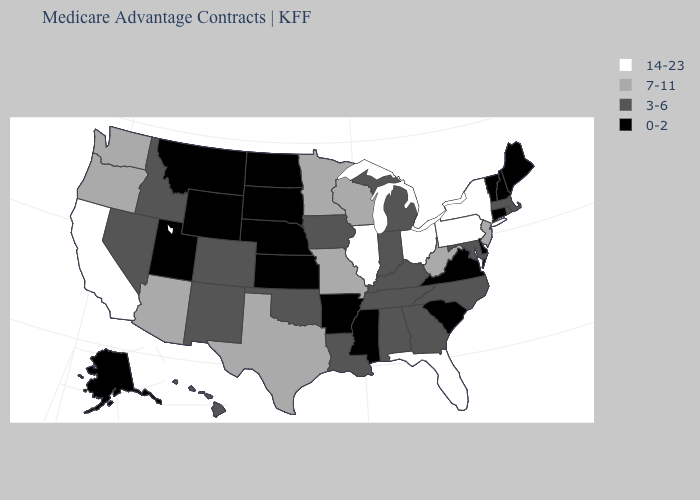What is the value of South Carolina?
Answer briefly. 0-2. Which states hav the highest value in the MidWest?
Give a very brief answer. Illinois, Ohio. Among the states that border Mississippi , which have the lowest value?
Quick response, please. Arkansas. Name the states that have a value in the range 3-6?
Keep it brief. Alabama, Colorado, Georgia, Hawaii, Iowa, Idaho, Indiana, Kentucky, Louisiana, Massachusetts, Maryland, Michigan, North Carolina, New Mexico, Nevada, Oklahoma, Rhode Island, Tennessee. Name the states that have a value in the range 7-11?
Write a very short answer. Arizona, Minnesota, Missouri, New Jersey, Oregon, Texas, Washington, Wisconsin, West Virginia. What is the value of Hawaii?
Give a very brief answer. 3-6. What is the value of Michigan?
Answer briefly. 3-6. Does Washington have a lower value than New York?
Short answer required. Yes. Name the states that have a value in the range 0-2?
Write a very short answer. Alaska, Arkansas, Connecticut, Delaware, Kansas, Maine, Mississippi, Montana, North Dakota, Nebraska, New Hampshire, South Carolina, South Dakota, Utah, Virginia, Vermont, Wyoming. Which states have the lowest value in the South?
Write a very short answer. Arkansas, Delaware, Mississippi, South Carolina, Virginia. What is the value of West Virginia?
Keep it brief. 7-11. Name the states that have a value in the range 7-11?
Write a very short answer. Arizona, Minnesota, Missouri, New Jersey, Oregon, Texas, Washington, Wisconsin, West Virginia. What is the value of South Dakota?
Answer briefly. 0-2. Does the first symbol in the legend represent the smallest category?
Keep it brief. No. 